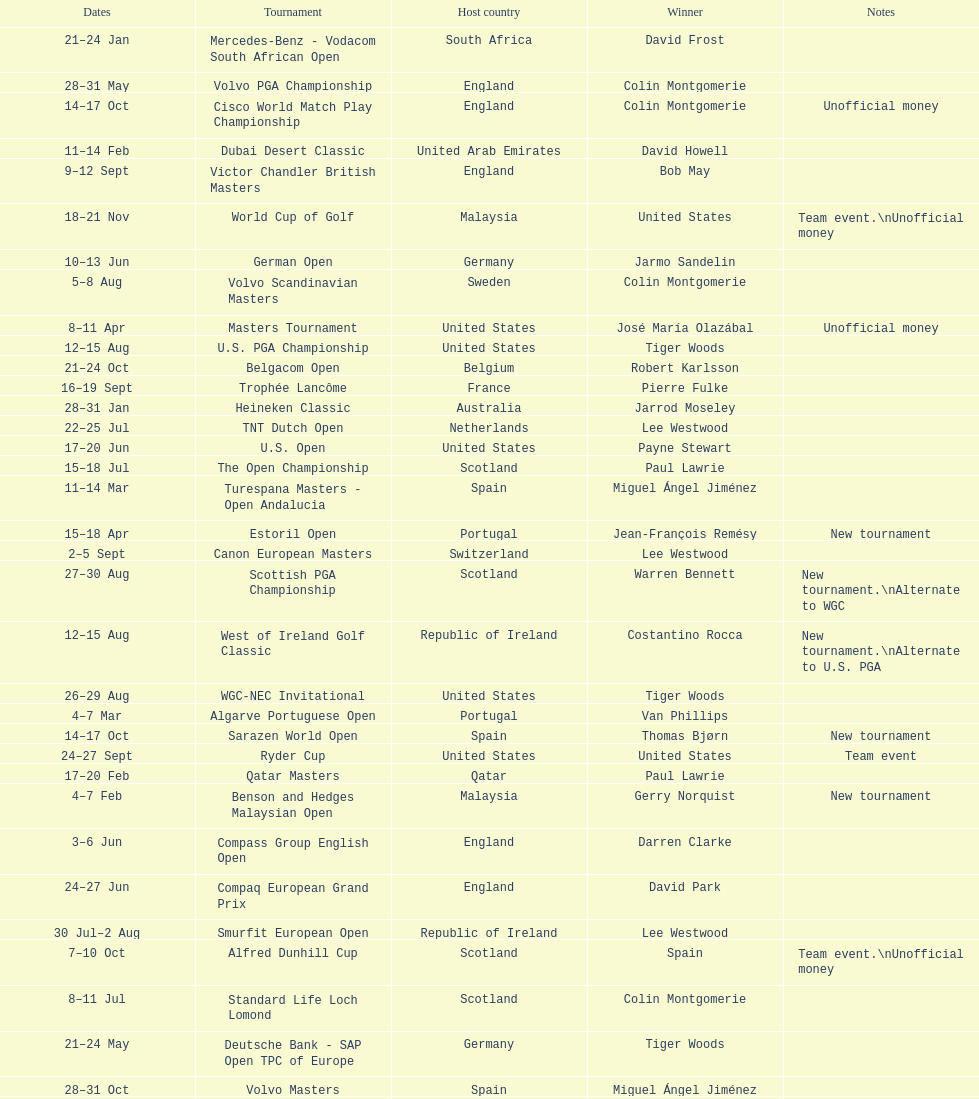How many tournaments began before aug 15th 31. 